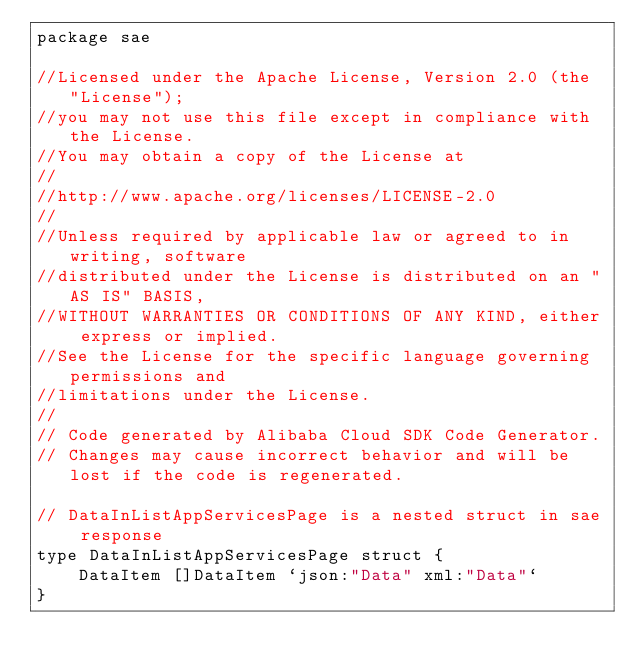Convert code to text. <code><loc_0><loc_0><loc_500><loc_500><_Go_>package sae

//Licensed under the Apache License, Version 2.0 (the "License");
//you may not use this file except in compliance with the License.
//You may obtain a copy of the License at
//
//http://www.apache.org/licenses/LICENSE-2.0
//
//Unless required by applicable law or agreed to in writing, software
//distributed under the License is distributed on an "AS IS" BASIS,
//WITHOUT WARRANTIES OR CONDITIONS OF ANY KIND, either express or implied.
//See the License for the specific language governing permissions and
//limitations under the License.
//
// Code generated by Alibaba Cloud SDK Code Generator.
// Changes may cause incorrect behavior and will be lost if the code is regenerated.

// DataInListAppServicesPage is a nested struct in sae response
type DataInListAppServicesPage struct {
	DataItem []DataItem `json:"Data" xml:"Data"`
}
</code> 